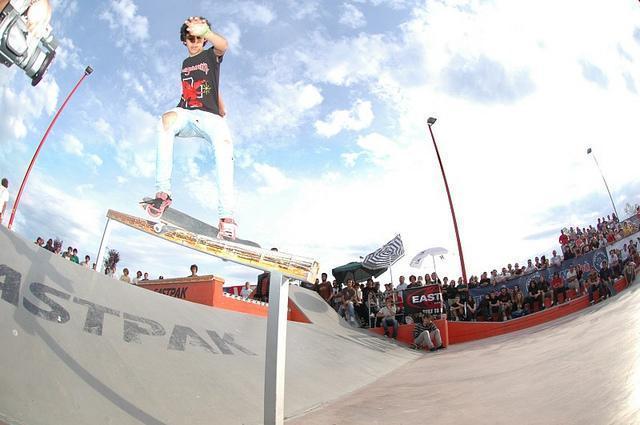How many people are there?
Give a very brief answer. 2. 